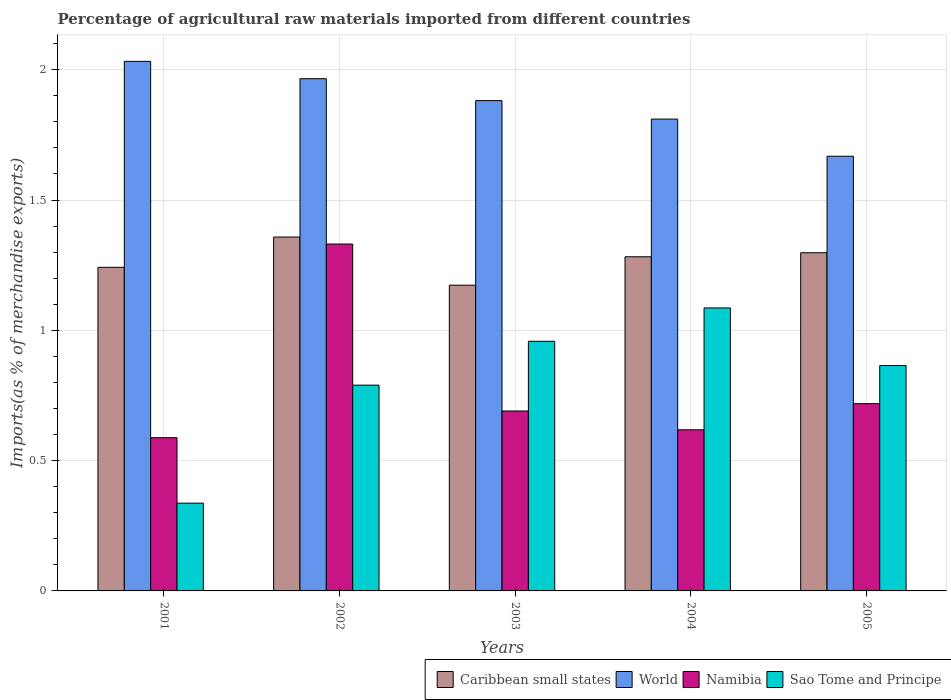How many bars are there on the 4th tick from the left?
Make the answer very short. 4. What is the label of the 5th group of bars from the left?
Provide a short and direct response. 2005. In how many cases, is the number of bars for a given year not equal to the number of legend labels?
Offer a terse response. 0. What is the percentage of imports to different countries in World in 2003?
Your response must be concise. 1.88. Across all years, what is the maximum percentage of imports to different countries in Sao Tome and Principe?
Offer a very short reply. 1.09. Across all years, what is the minimum percentage of imports to different countries in Caribbean small states?
Ensure brevity in your answer.  1.17. In which year was the percentage of imports to different countries in World maximum?
Make the answer very short. 2001. In which year was the percentage of imports to different countries in Namibia minimum?
Offer a very short reply. 2001. What is the total percentage of imports to different countries in Sao Tome and Principe in the graph?
Offer a very short reply. 4.04. What is the difference between the percentage of imports to different countries in Caribbean small states in 2001 and that in 2002?
Offer a terse response. -0.12. What is the difference between the percentage of imports to different countries in Caribbean small states in 2003 and the percentage of imports to different countries in World in 2002?
Ensure brevity in your answer.  -0.79. What is the average percentage of imports to different countries in Sao Tome and Principe per year?
Make the answer very short. 0.81. In the year 2005, what is the difference between the percentage of imports to different countries in Namibia and percentage of imports to different countries in World?
Give a very brief answer. -0.95. In how many years, is the percentage of imports to different countries in Sao Tome and Principe greater than 0.7 %?
Offer a terse response. 4. What is the ratio of the percentage of imports to different countries in World in 2003 to that in 2004?
Provide a succinct answer. 1.04. Is the difference between the percentage of imports to different countries in Namibia in 2002 and 2005 greater than the difference between the percentage of imports to different countries in World in 2002 and 2005?
Offer a terse response. Yes. What is the difference between the highest and the second highest percentage of imports to different countries in Namibia?
Provide a succinct answer. 0.61. What is the difference between the highest and the lowest percentage of imports to different countries in Namibia?
Offer a terse response. 0.74. Is it the case that in every year, the sum of the percentage of imports to different countries in Caribbean small states and percentage of imports to different countries in Sao Tome and Principe is greater than the sum of percentage of imports to different countries in Namibia and percentage of imports to different countries in World?
Provide a short and direct response. No. What does the 4th bar from the left in 2005 represents?
Your answer should be compact. Sao Tome and Principe. What does the 3rd bar from the right in 2002 represents?
Your response must be concise. World. How many bars are there?
Keep it short and to the point. 20. What is the difference between two consecutive major ticks on the Y-axis?
Provide a succinct answer. 0.5. Are the values on the major ticks of Y-axis written in scientific E-notation?
Keep it short and to the point. No. Does the graph contain any zero values?
Your answer should be very brief. No. Does the graph contain grids?
Ensure brevity in your answer.  Yes. How many legend labels are there?
Your response must be concise. 4. What is the title of the graph?
Your answer should be very brief. Percentage of agricultural raw materials imported from different countries. Does "Comoros" appear as one of the legend labels in the graph?
Make the answer very short. No. What is the label or title of the Y-axis?
Your answer should be compact. Imports(as % of merchandise exports). What is the Imports(as % of merchandise exports) of Caribbean small states in 2001?
Ensure brevity in your answer.  1.24. What is the Imports(as % of merchandise exports) in World in 2001?
Provide a short and direct response. 2.03. What is the Imports(as % of merchandise exports) of Namibia in 2001?
Your response must be concise. 0.59. What is the Imports(as % of merchandise exports) in Sao Tome and Principe in 2001?
Offer a very short reply. 0.34. What is the Imports(as % of merchandise exports) in Caribbean small states in 2002?
Provide a succinct answer. 1.36. What is the Imports(as % of merchandise exports) of World in 2002?
Your answer should be very brief. 1.97. What is the Imports(as % of merchandise exports) in Namibia in 2002?
Your answer should be compact. 1.33. What is the Imports(as % of merchandise exports) in Sao Tome and Principe in 2002?
Offer a very short reply. 0.79. What is the Imports(as % of merchandise exports) in Caribbean small states in 2003?
Your answer should be compact. 1.17. What is the Imports(as % of merchandise exports) in World in 2003?
Make the answer very short. 1.88. What is the Imports(as % of merchandise exports) in Namibia in 2003?
Give a very brief answer. 0.69. What is the Imports(as % of merchandise exports) in Sao Tome and Principe in 2003?
Your answer should be compact. 0.96. What is the Imports(as % of merchandise exports) of Caribbean small states in 2004?
Ensure brevity in your answer.  1.28. What is the Imports(as % of merchandise exports) of World in 2004?
Ensure brevity in your answer.  1.81. What is the Imports(as % of merchandise exports) of Namibia in 2004?
Provide a succinct answer. 0.62. What is the Imports(as % of merchandise exports) of Sao Tome and Principe in 2004?
Your answer should be compact. 1.09. What is the Imports(as % of merchandise exports) in Caribbean small states in 2005?
Offer a very short reply. 1.3. What is the Imports(as % of merchandise exports) in World in 2005?
Offer a very short reply. 1.67. What is the Imports(as % of merchandise exports) in Namibia in 2005?
Provide a short and direct response. 0.72. What is the Imports(as % of merchandise exports) of Sao Tome and Principe in 2005?
Give a very brief answer. 0.86. Across all years, what is the maximum Imports(as % of merchandise exports) in Caribbean small states?
Offer a terse response. 1.36. Across all years, what is the maximum Imports(as % of merchandise exports) in World?
Make the answer very short. 2.03. Across all years, what is the maximum Imports(as % of merchandise exports) in Namibia?
Your response must be concise. 1.33. Across all years, what is the maximum Imports(as % of merchandise exports) in Sao Tome and Principe?
Offer a terse response. 1.09. Across all years, what is the minimum Imports(as % of merchandise exports) in Caribbean small states?
Make the answer very short. 1.17. Across all years, what is the minimum Imports(as % of merchandise exports) in World?
Ensure brevity in your answer.  1.67. Across all years, what is the minimum Imports(as % of merchandise exports) in Namibia?
Provide a succinct answer. 0.59. Across all years, what is the minimum Imports(as % of merchandise exports) of Sao Tome and Principe?
Your answer should be very brief. 0.34. What is the total Imports(as % of merchandise exports) of Caribbean small states in the graph?
Offer a very short reply. 6.35. What is the total Imports(as % of merchandise exports) of World in the graph?
Ensure brevity in your answer.  9.36. What is the total Imports(as % of merchandise exports) of Namibia in the graph?
Your answer should be very brief. 3.95. What is the total Imports(as % of merchandise exports) of Sao Tome and Principe in the graph?
Keep it short and to the point. 4.04. What is the difference between the Imports(as % of merchandise exports) in Caribbean small states in 2001 and that in 2002?
Offer a terse response. -0.12. What is the difference between the Imports(as % of merchandise exports) in World in 2001 and that in 2002?
Provide a short and direct response. 0.07. What is the difference between the Imports(as % of merchandise exports) in Namibia in 2001 and that in 2002?
Your answer should be very brief. -0.74. What is the difference between the Imports(as % of merchandise exports) of Sao Tome and Principe in 2001 and that in 2002?
Offer a terse response. -0.45. What is the difference between the Imports(as % of merchandise exports) of Caribbean small states in 2001 and that in 2003?
Give a very brief answer. 0.07. What is the difference between the Imports(as % of merchandise exports) of World in 2001 and that in 2003?
Give a very brief answer. 0.15. What is the difference between the Imports(as % of merchandise exports) of Namibia in 2001 and that in 2003?
Keep it short and to the point. -0.1. What is the difference between the Imports(as % of merchandise exports) of Sao Tome and Principe in 2001 and that in 2003?
Your answer should be very brief. -0.62. What is the difference between the Imports(as % of merchandise exports) in Caribbean small states in 2001 and that in 2004?
Your response must be concise. -0.04. What is the difference between the Imports(as % of merchandise exports) in World in 2001 and that in 2004?
Offer a very short reply. 0.22. What is the difference between the Imports(as % of merchandise exports) of Namibia in 2001 and that in 2004?
Your response must be concise. -0.03. What is the difference between the Imports(as % of merchandise exports) in Sao Tome and Principe in 2001 and that in 2004?
Make the answer very short. -0.75. What is the difference between the Imports(as % of merchandise exports) in Caribbean small states in 2001 and that in 2005?
Ensure brevity in your answer.  -0.06. What is the difference between the Imports(as % of merchandise exports) of World in 2001 and that in 2005?
Your answer should be compact. 0.36. What is the difference between the Imports(as % of merchandise exports) of Namibia in 2001 and that in 2005?
Your response must be concise. -0.13. What is the difference between the Imports(as % of merchandise exports) of Sao Tome and Principe in 2001 and that in 2005?
Give a very brief answer. -0.53. What is the difference between the Imports(as % of merchandise exports) in Caribbean small states in 2002 and that in 2003?
Ensure brevity in your answer.  0.18. What is the difference between the Imports(as % of merchandise exports) of World in 2002 and that in 2003?
Keep it short and to the point. 0.08. What is the difference between the Imports(as % of merchandise exports) in Namibia in 2002 and that in 2003?
Keep it short and to the point. 0.64. What is the difference between the Imports(as % of merchandise exports) of Sao Tome and Principe in 2002 and that in 2003?
Offer a terse response. -0.17. What is the difference between the Imports(as % of merchandise exports) of Caribbean small states in 2002 and that in 2004?
Your response must be concise. 0.08. What is the difference between the Imports(as % of merchandise exports) of World in 2002 and that in 2004?
Offer a terse response. 0.15. What is the difference between the Imports(as % of merchandise exports) of Namibia in 2002 and that in 2004?
Ensure brevity in your answer.  0.71. What is the difference between the Imports(as % of merchandise exports) in Sao Tome and Principe in 2002 and that in 2004?
Provide a short and direct response. -0.3. What is the difference between the Imports(as % of merchandise exports) in Caribbean small states in 2002 and that in 2005?
Provide a short and direct response. 0.06. What is the difference between the Imports(as % of merchandise exports) in World in 2002 and that in 2005?
Ensure brevity in your answer.  0.3. What is the difference between the Imports(as % of merchandise exports) in Namibia in 2002 and that in 2005?
Offer a very short reply. 0.61. What is the difference between the Imports(as % of merchandise exports) in Sao Tome and Principe in 2002 and that in 2005?
Your answer should be compact. -0.08. What is the difference between the Imports(as % of merchandise exports) of Caribbean small states in 2003 and that in 2004?
Provide a short and direct response. -0.11. What is the difference between the Imports(as % of merchandise exports) of World in 2003 and that in 2004?
Keep it short and to the point. 0.07. What is the difference between the Imports(as % of merchandise exports) of Namibia in 2003 and that in 2004?
Offer a very short reply. 0.07. What is the difference between the Imports(as % of merchandise exports) of Sao Tome and Principe in 2003 and that in 2004?
Offer a very short reply. -0.13. What is the difference between the Imports(as % of merchandise exports) in Caribbean small states in 2003 and that in 2005?
Give a very brief answer. -0.12. What is the difference between the Imports(as % of merchandise exports) of World in 2003 and that in 2005?
Your answer should be very brief. 0.21. What is the difference between the Imports(as % of merchandise exports) in Namibia in 2003 and that in 2005?
Ensure brevity in your answer.  -0.03. What is the difference between the Imports(as % of merchandise exports) in Sao Tome and Principe in 2003 and that in 2005?
Your response must be concise. 0.09. What is the difference between the Imports(as % of merchandise exports) of Caribbean small states in 2004 and that in 2005?
Your answer should be compact. -0.02. What is the difference between the Imports(as % of merchandise exports) of World in 2004 and that in 2005?
Your answer should be very brief. 0.14. What is the difference between the Imports(as % of merchandise exports) of Namibia in 2004 and that in 2005?
Keep it short and to the point. -0.1. What is the difference between the Imports(as % of merchandise exports) of Sao Tome and Principe in 2004 and that in 2005?
Provide a succinct answer. 0.22. What is the difference between the Imports(as % of merchandise exports) in Caribbean small states in 2001 and the Imports(as % of merchandise exports) in World in 2002?
Give a very brief answer. -0.72. What is the difference between the Imports(as % of merchandise exports) of Caribbean small states in 2001 and the Imports(as % of merchandise exports) of Namibia in 2002?
Provide a succinct answer. -0.09. What is the difference between the Imports(as % of merchandise exports) of Caribbean small states in 2001 and the Imports(as % of merchandise exports) of Sao Tome and Principe in 2002?
Your answer should be very brief. 0.45. What is the difference between the Imports(as % of merchandise exports) of World in 2001 and the Imports(as % of merchandise exports) of Namibia in 2002?
Make the answer very short. 0.7. What is the difference between the Imports(as % of merchandise exports) of World in 2001 and the Imports(as % of merchandise exports) of Sao Tome and Principe in 2002?
Your answer should be very brief. 1.24. What is the difference between the Imports(as % of merchandise exports) of Namibia in 2001 and the Imports(as % of merchandise exports) of Sao Tome and Principe in 2002?
Provide a succinct answer. -0.2. What is the difference between the Imports(as % of merchandise exports) of Caribbean small states in 2001 and the Imports(as % of merchandise exports) of World in 2003?
Offer a very short reply. -0.64. What is the difference between the Imports(as % of merchandise exports) in Caribbean small states in 2001 and the Imports(as % of merchandise exports) in Namibia in 2003?
Your response must be concise. 0.55. What is the difference between the Imports(as % of merchandise exports) in Caribbean small states in 2001 and the Imports(as % of merchandise exports) in Sao Tome and Principe in 2003?
Provide a short and direct response. 0.28. What is the difference between the Imports(as % of merchandise exports) in World in 2001 and the Imports(as % of merchandise exports) in Namibia in 2003?
Provide a short and direct response. 1.34. What is the difference between the Imports(as % of merchandise exports) of World in 2001 and the Imports(as % of merchandise exports) of Sao Tome and Principe in 2003?
Offer a very short reply. 1.07. What is the difference between the Imports(as % of merchandise exports) in Namibia in 2001 and the Imports(as % of merchandise exports) in Sao Tome and Principe in 2003?
Offer a terse response. -0.37. What is the difference between the Imports(as % of merchandise exports) in Caribbean small states in 2001 and the Imports(as % of merchandise exports) in World in 2004?
Offer a very short reply. -0.57. What is the difference between the Imports(as % of merchandise exports) of Caribbean small states in 2001 and the Imports(as % of merchandise exports) of Namibia in 2004?
Offer a very short reply. 0.62. What is the difference between the Imports(as % of merchandise exports) of Caribbean small states in 2001 and the Imports(as % of merchandise exports) of Sao Tome and Principe in 2004?
Your answer should be very brief. 0.16. What is the difference between the Imports(as % of merchandise exports) in World in 2001 and the Imports(as % of merchandise exports) in Namibia in 2004?
Make the answer very short. 1.41. What is the difference between the Imports(as % of merchandise exports) in World in 2001 and the Imports(as % of merchandise exports) in Sao Tome and Principe in 2004?
Give a very brief answer. 0.95. What is the difference between the Imports(as % of merchandise exports) of Namibia in 2001 and the Imports(as % of merchandise exports) of Sao Tome and Principe in 2004?
Give a very brief answer. -0.5. What is the difference between the Imports(as % of merchandise exports) in Caribbean small states in 2001 and the Imports(as % of merchandise exports) in World in 2005?
Give a very brief answer. -0.43. What is the difference between the Imports(as % of merchandise exports) of Caribbean small states in 2001 and the Imports(as % of merchandise exports) of Namibia in 2005?
Make the answer very short. 0.52. What is the difference between the Imports(as % of merchandise exports) in Caribbean small states in 2001 and the Imports(as % of merchandise exports) in Sao Tome and Principe in 2005?
Your answer should be very brief. 0.38. What is the difference between the Imports(as % of merchandise exports) in World in 2001 and the Imports(as % of merchandise exports) in Namibia in 2005?
Your answer should be compact. 1.31. What is the difference between the Imports(as % of merchandise exports) in World in 2001 and the Imports(as % of merchandise exports) in Sao Tome and Principe in 2005?
Make the answer very short. 1.17. What is the difference between the Imports(as % of merchandise exports) of Namibia in 2001 and the Imports(as % of merchandise exports) of Sao Tome and Principe in 2005?
Provide a succinct answer. -0.28. What is the difference between the Imports(as % of merchandise exports) in Caribbean small states in 2002 and the Imports(as % of merchandise exports) in World in 2003?
Your answer should be compact. -0.52. What is the difference between the Imports(as % of merchandise exports) in Caribbean small states in 2002 and the Imports(as % of merchandise exports) in Namibia in 2003?
Provide a succinct answer. 0.67. What is the difference between the Imports(as % of merchandise exports) of World in 2002 and the Imports(as % of merchandise exports) of Namibia in 2003?
Offer a very short reply. 1.28. What is the difference between the Imports(as % of merchandise exports) in World in 2002 and the Imports(as % of merchandise exports) in Sao Tome and Principe in 2003?
Offer a very short reply. 1.01. What is the difference between the Imports(as % of merchandise exports) in Namibia in 2002 and the Imports(as % of merchandise exports) in Sao Tome and Principe in 2003?
Your response must be concise. 0.37. What is the difference between the Imports(as % of merchandise exports) in Caribbean small states in 2002 and the Imports(as % of merchandise exports) in World in 2004?
Your answer should be very brief. -0.45. What is the difference between the Imports(as % of merchandise exports) in Caribbean small states in 2002 and the Imports(as % of merchandise exports) in Namibia in 2004?
Provide a short and direct response. 0.74. What is the difference between the Imports(as % of merchandise exports) in Caribbean small states in 2002 and the Imports(as % of merchandise exports) in Sao Tome and Principe in 2004?
Offer a terse response. 0.27. What is the difference between the Imports(as % of merchandise exports) in World in 2002 and the Imports(as % of merchandise exports) in Namibia in 2004?
Your answer should be very brief. 1.35. What is the difference between the Imports(as % of merchandise exports) in World in 2002 and the Imports(as % of merchandise exports) in Sao Tome and Principe in 2004?
Provide a short and direct response. 0.88. What is the difference between the Imports(as % of merchandise exports) in Namibia in 2002 and the Imports(as % of merchandise exports) in Sao Tome and Principe in 2004?
Provide a short and direct response. 0.25. What is the difference between the Imports(as % of merchandise exports) of Caribbean small states in 2002 and the Imports(as % of merchandise exports) of World in 2005?
Offer a very short reply. -0.31. What is the difference between the Imports(as % of merchandise exports) in Caribbean small states in 2002 and the Imports(as % of merchandise exports) in Namibia in 2005?
Keep it short and to the point. 0.64. What is the difference between the Imports(as % of merchandise exports) in Caribbean small states in 2002 and the Imports(as % of merchandise exports) in Sao Tome and Principe in 2005?
Offer a very short reply. 0.49. What is the difference between the Imports(as % of merchandise exports) of World in 2002 and the Imports(as % of merchandise exports) of Namibia in 2005?
Your answer should be very brief. 1.25. What is the difference between the Imports(as % of merchandise exports) of World in 2002 and the Imports(as % of merchandise exports) of Sao Tome and Principe in 2005?
Make the answer very short. 1.1. What is the difference between the Imports(as % of merchandise exports) of Namibia in 2002 and the Imports(as % of merchandise exports) of Sao Tome and Principe in 2005?
Offer a terse response. 0.47. What is the difference between the Imports(as % of merchandise exports) of Caribbean small states in 2003 and the Imports(as % of merchandise exports) of World in 2004?
Provide a short and direct response. -0.64. What is the difference between the Imports(as % of merchandise exports) in Caribbean small states in 2003 and the Imports(as % of merchandise exports) in Namibia in 2004?
Your response must be concise. 0.56. What is the difference between the Imports(as % of merchandise exports) of Caribbean small states in 2003 and the Imports(as % of merchandise exports) of Sao Tome and Principe in 2004?
Provide a succinct answer. 0.09. What is the difference between the Imports(as % of merchandise exports) of World in 2003 and the Imports(as % of merchandise exports) of Namibia in 2004?
Make the answer very short. 1.26. What is the difference between the Imports(as % of merchandise exports) in World in 2003 and the Imports(as % of merchandise exports) in Sao Tome and Principe in 2004?
Keep it short and to the point. 0.8. What is the difference between the Imports(as % of merchandise exports) in Namibia in 2003 and the Imports(as % of merchandise exports) in Sao Tome and Principe in 2004?
Ensure brevity in your answer.  -0.4. What is the difference between the Imports(as % of merchandise exports) of Caribbean small states in 2003 and the Imports(as % of merchandise exports) of World in 2005?
Provide a short and direct response. -0.49. What is the difference between the Imports(as % of merchandise exports) in Caribbean small states in 2003 and the Imports(as % of merchandise exports) in Namibia in 2005?
Your answer should be compact. 0.45. What is the difference between the Imports(as % of merchandise exports) of Caribbean small states in 2003 and the Imports(as % of merchandise exports) of Sao Tome and Principe in 2005?
Provide a succinct answer. 0.31. What is the difference between the Imports(as % of merchandise exports) in World in 2003 and the Imports(as % of merchandise exports) in Namibia in 2005?
Provide a succinct answer. 1.16. What is the difference between the Imports(as % of merchandise exports) of World in 2003 and the Imports(as % of merchandise exports) of Sao Tome and Principe in 2005?
Provide a succinct answer. 1.02. What is the difference between the Imports(as % of merchandise exports) of Namibia in 2003 and the Imports(as % of merchandise exports) of Sao Tome and Principe in 2005?
Make the answer very short. -0.17. What is the difference between the Imports(as % of merchandise exports) in Caribbean small states in 2004 and the Imports(as % of merchandise exports) in World in 2005?
Provide a succinct answer. -0.39. What is the difference between the Imports(as % of merchandise exports) in Caribbean small states in 2004 and the Imports(as % of merchandise exports) in Namibia in 2005?
Ensure brevity in your answer.  0.56. What is the difference between the Imports(as % of merchandise exports) in Caribbean small states in 2004 and the Imports(as % of merchandise exports) in Sao Tome and Principe in 2005?
Your answer should be very brief. 0.42. What is the difference between the Imports(as % of merchandise exports) of World in 2004 and the Imports(as % of merchandise exports) of Namibia in 2005?
Offer a terse response. 1.09. What is the difference between the Imports(as % of merchandise exports) in World in 2004 and the Imports(as % of merchandise exports) in Sao Tome and Principe in 2005?
Make the answer very short. 0.95. What is the difference between the Imports(as % of merchandise exports) of Namibia in 2004 and the Imports(as % of merchandise exports) of Sao Tome and Principe in 2005?
Provide a succinct answer. -0.25. What is the average Imports(as % of merchandise exports) of Caribbean small states per year?
Your answer should be very brief. 1.27. What is the average Imports(as % of merchandise exports) of World per year?
Keep it short and to the point. 1.87. What is the average Imports(as % of merchandise exports) in Namibia per year?
Make the answer very short. 0.79. What is the average Imports(as % of merchandise exports) in Sao Tome and Principe per year?
Give a very brief answer. 0.81. In the year 2001, what is the difference between the Imports(as % of merchandise exports) of Caribbean small states and Imports(as % of merchandise exports) of World?
Ensure brevity in your answer.  -0.79. In the year 2001, what is the difference between the Imports(as % of merchandise exports) of Caribbean small states and Imports(as % of merchandise exports) of Namibia?
Offer a very short reply. 0.65. In the year 2001, what is the difference between the Imports(as % of merchandise exports) of Caribbean small states and Imports(as % of merchandise exports) of Sao Tome and Principe?
Your answer should be compact. 0.91. In the year 2001, what is the difference between the Imports(as % of merchandise exports) of World and Imports(as % of merchandise exports) of Namibia?
Your answer should be compact. 1.44. In the year 2001, what is the difference between the Imports(as % of merchandise exports) in World and Imports(as % of merchandise exports) in Sao Tome and Principe?
Offer a very short reply. 1.7. In the year 2001, what is the difference between the Imports(as % of merchandise exports) of Namibia and Imports(as % of merchandise exports) of Sao Tome and Principe?
Provide a short and direct response. 0.25. In the year 2002, what is the difference between the Imports(as % of merchandise exports) of Caribbean small states and Imports(as % of merchandise exports) of World?
Ensure brevity in your answer.  -0.61. In the year 2002, what is the difference between the Imports(as % of merchandise exports) of Caribbean small states and Imports(as % of merchandise exports) of Namibia?
Offer a very short reply. 0.03. In the year 2002, what is the difference between the Imports(as % of merchandise exports) of Caribbean small states and Imports(as % of merchandise exports) of Sao Tome and Principe?
Your response must be concise. 0.57. In the year 2002, what is the difference between the Imports(as % of merchandise exports) of World and Imports(as % of merchandise exports) of Namibia?
Your response must be concise. 0.63. In the year 2002, what is the difference between the Imports(as % of merchandise exports) of World and Imports(as % of merchandise exports) of Sao Tome and Principe?
Give a very brief answer. 1.18. In the year 2002, what is the difference between the Imports(as % of merchandise exports) of Namibia and Imports(as % of merchandise exports) of Sao Tome and Principe?
Make the answer very short. 0.54. In the year 2003, what is the difference between the Imports(as % of merchandise exports) of Caribbean small states and Imports(as % of merchandise exports) of World?
Offer a very short reply. -0.71. In the year 2003, what is the difference between the Imports(as % of merchandise exports) in Caribbean small states and Imports(as % of merchandise exports) in Namibia?
Make the answer very short. 0.48. In the year 2003, what is the difference between the Imports(as % of merchandise exports) in Caribbean small states and Imports(as % of merchandise exports) in Sao Tome and Principe?
Make the answer very short. 0.22. In the year 2003, what is the difference between the Imports(as % of merchandise exports) of World and Imports(as % of merchandise exports) of Namibia?
Make the answer very short. 1.19. In the year 2003, what is the difference between the Imports(as % of merchandise exports) in World and Imports(as % of merchandise exports) in Sao Tome and Principe?
Provide a short and direct response. 0.92. In the year 2003, what is the difference between the Imports(as % of merchandise exports) of Namibia and Imports(as % of merchandise exports) of Sao Tome and Principe?
Offer a very short reply. -0.27. In the year 2004, what is the difference between the Imports(as % of merchandise exports) of Caribbean small states and Imports(as % of merchandise exports) of World?
Ensure brevity in your answer.  -0.53. In the year 2004, what is the difference between the Imports(as % of merchandise exports) of Caribbean small states and Imports(as % of merchandise exports) of Namibia?
Your response must be concise. 0.66. In the year 2004, what is the difference between the Imports(as % of merchandise exports) in Caribbean small states and Imports(as % of merchandise exports) in Sao Tome and Principe?
Provide a short and direct response. 0.2. In the year 2004, what is the difference between the Imports(as % of merchandise exports) of World and Imports(as % of merchandise exports) of Namibia?
Your response must be concise. 1.19. In the year 2004, what is the difference between the Imports(as % of merchandise exports) in World and Imports(as % of merchandise exports) in Sao Tome and Principe?
Give a very brief answer. 0.72. In the year 2004, what is the difference between the Imports(as % of merchandise exports) of Namibia and Imports(as % of merchandise exports) of Sao Tome and Principe?
Make the answer very short. -0.47. In the year 2005, what is the difference between the Imports(as % of merchandise exports) of Caribbean small states and Imports(as % of merchandise exports) of World?
Your answer should be compact. -0.37. In the year 2005, what is the difference between the Imports(as % of merchandise exports) in Caribbean small states and Imports(as % of merchandise exports) in Namibia?
Offer a very short reply. 0.58. In the year 2005, what is the difference between the Imports(as % of merchandise exports) of Caribbean small states and Imports(as % of merchandise exports) of Sao Tome and Principe?
Make the answer very short. 0.43. In the year 2005, what is the difference between the Imports(as % of merchandise exports) of World and Imports(as % of merchandise exports) of Namibia?
Offer a terse response. 0.95. In the year 2005, what is the difference between the Imports(as % of merchandise exports) in World and Imports(as % of merchandise exports) in Sao Tome and Principe?
Make the answer very short. 0.8. In the year 2005, what is the difference between the Imports(as % of merchandise exports) in Namibia and Imports(as % of merchandise exports) in Sao Tome and Principe?
Make the answer very short. -0.15. What is the ratio of the Imports(as % of merchandise exports) in Caribbean small states in 2001 to that in 2002?
Offer a terse response. 0.91. What is the ratio of the Imports(as % of merchandise exports) in World in 2001 to that in 2002?
Offer a very short reply. 1.03. What is the ratio of the Imports(as % of merchandise exports) of Namibia in 2001 to that in 2002?
Ensure brevity in your answer.  0.44. What is the ratio of the Imports(as % of merchandise exports) in Sao Tome and Principe in 2001 to that in 2002?
Make the answer very short. 0.43. What is the ratio of the Imports(as % of merchandise exports) of Caribbean small states in 2001 to that in 2003?
Offer a very short reply. 1.06. What is the ratio of the Imports(as % of merchandise exports) of World in 2001 to that in 2003?
Your answer should be compact. 1.08. What is the ratio of the Imports(as % of merchandise exports) of Namibia in 2001 to that in 2003?
Give a very brief answer. 0.85. What is the ratio of the Imports(as % of merchandise exports) of Sao Tome and Principe in 2001 to that in 2003?
Keep it short and to the point. 0.35. What is the ratio of the Imports(as % of merchandise exports) of Caribbean small states in 2001 to that in 2004?
Offer a very short reply. 0.97. What is the ratio of the Imports(as % of merchandise exports) in World in 2001 to that in 2004?
Your answer should be very brief. 1.12. What is the ratio of the Imports(as % of merchandise exports) of Namibia in 2001 to that in 2004?
Offer a terse response. 0.95. What is the ratio of the Imports(as % of merchandise exports) of Sao Tome and Principe in 2001 to that in 2004?
Provide a short and direct response. 0.31. What is the ratio of the Imports(as % of merchandise exports) in Caribbean small states in 2001 to that in 2005?
Provide a succinct answer. 0.96. What is the ratio of the Imports(as % of merchandise exports) of World in 2001 to that in 2005?
Provide a succinct answer. 1.22. What is the ratio of the Imports(as % of merchandise exports) of Namibia in 2001 to that in 2005?
Provide a succinct answer. 0.82. What is the ratio of the Imports(as % of merchandise exports) of Sao Tome and Principe in 2001 to that in 2005?
Your answer should be compact. 0.39. What is the ratio of the Imports(as % of merchandise exports) of Caribbean small states in 2002 to that in 2003?
Offer a very short reply. 1.16. What is the ratio of the Imports(as % of merchandise exports) of World in 2002 to that in 2003?
Your response must be concise. 1.04. What is the ratio of the Imports(as % of merchandise exports) in Namibia in 2002 to that in 2003?
Provide a short and direct response. 1.93. What is the ratio of the Imports(as % of merchandise exports) of Sao Tome and Principe in 2002 to that in 2003?
Your response must be concise. 0.82. What is the ratio of the Imports(as % of merchandise exports) in Caribbean small states in 2002 to that in 2004?
Your answer should be very brief. 1.06. What is the ratio of the Imports(as % of merchandise exports) in World in 2002 to that in 2004?
Your response must be concise. 1.09. What is the ratio of the Imports(as % of merchandise exports) in Namibia in 2002 to that in 2004?
Offer a terse response. 2.15. What is the ratio of the Imports(as % of merchandise exports) in Sao Tome and Principe in 2002 to that in 2004?
Keep it short and to the point. 0.73. What is the ratio of the Imports(as % of merchandise exports) in Caribbean small states in 2002 to that in 2005?
Give a very brief answer. 1.05. What is the ratio of the Imports(as % of merchandise exports) of World in 2002 to that in 2005?
Your answer should be compact. 1.18. What is the ratio of the Imports(as % of merchandise exports) in Namibia in 2002 to that in 2005?
Make the answer very short. 1.85. What is the ratio of the Imports(as % of merchandise exports) in Sao Tome and Principe in 2002 to that in 2005?
Provide a short and direct response. 0.91. What is the ratio of the Imports(as % of merchandise exports) in Caribbean small states in 2003 to that in 2004?
Provide a succinct answer. 0.92. What is the ratio of the Imports(as % of merchandise exports) in World in 2003 to that in 2004?
Ensure brevity in your answer.  1.04. What is the ratio of the Imports(as % of merchandise exports) in Namibia in 2003 to that in 2004?
Your response must be concise. 1.12. What is the ratio of the Imports(as % of merchandise exports) of Sao Tome and Principe in 2003 to that in 2004?
Give a very brief answer. 0.88. What is the ratio of the Imports(as % of merchandise exports) of Caribbean small states in 2003 to that in 2005?
Your response must be concise. 0.9. What is the ratio of the Imports(as % of merchandise exports) of World in 2003 to that in 2005?
Offer a very short reply. 1.13. What is the ratio of the Imports(as % of merchandise exports) in Namibia in 2003 to that in 2005?
Your answer should be very brief. 0.96. What is the ratio of the Imports(as % of merchandise exports) of Sao Tome and Principe in 2003 to that in 2005?
Keep it short and to the point. 1.11. What is the ratio of the Imports(as % of merchandise exports) in World in 2004 to that in 2005?
Provide a short and direct response. 1.09. What is the ratio of the Imports(as % of merchandise exports) of Namibia in 2004 to that in 2005?
Your response must be concise. 0.86. What is the ratio of the Imports(as % of merchandise exports) of Sao Tome and Principe in 2004 to that in 2005?
Keep it short and to the point. 1.26. What is the difference between the highest and the second highest Imports(as % of merchandise exports) in Caribbean small states?
Your response must be concise. 0.06. What is the difference between the highest and the second highest Imports(as % of merchandise exports) of World?
Your response must be concise. 0.07. What is the difference between the highest and the second highest Imports(as % of merchandise exports) in Namibia?
Offer a terse response. 0.61. What is the difference between the highest and the second highest Imports(as % of merchandise exports) in Sao Tome and Principe?
Keep it short and to the point. 0.13. What is the difference between the highest and the lowest Imports(as % of merchandise exports) of Caribbean small states?
Provide a short and direct response. 0.18. What is the difference between the highest and the lowest Imports(as % of merchandise exports) of World?
Make the answer very short. 0.36. What is the difference between the highest and the lowest Imports(as % of merchandise exports) in Namibia?
Your answer should be compact. 0.74. What is the difference between the highest and the lowest Imports(as % of merchandise exports) in Sao Tome and Principe?
Make the answer very short. 0.75. 